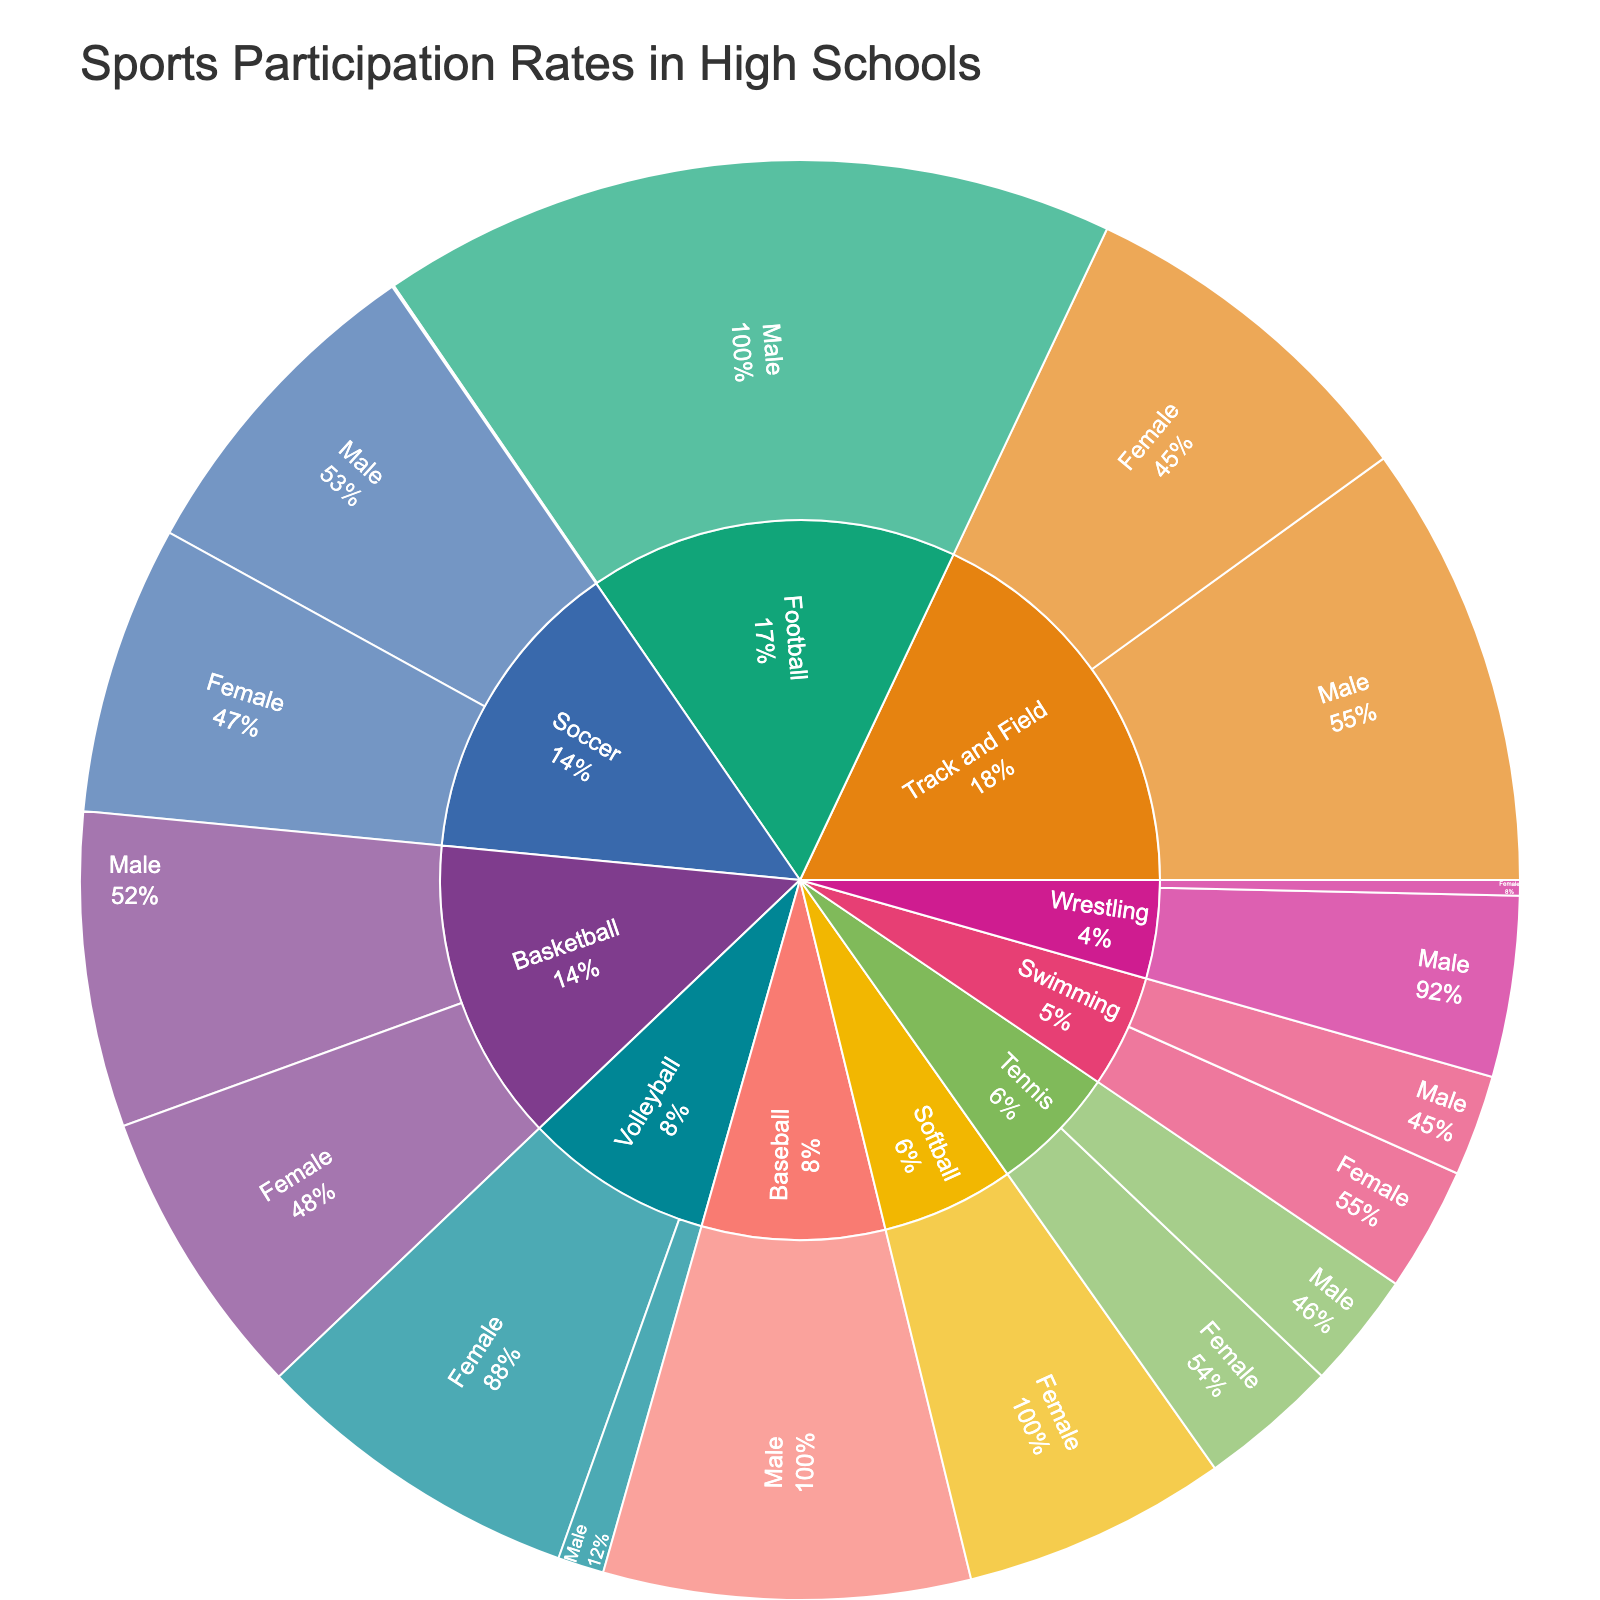what is the sport with the highest overall participation? The sunburst plot shows the participation rates broken down by sport and gender. Identify the largest segment in the plot, which corresponds to the sport with the highest overall participation. The largest segment is for Football (Male) with a count of 1,006,000.
Answer: Football how many students participate in Volleyball overall? Add the participation counts for both male and female Volleyball segments in the sunburst plot. Male Volleyball has 63,000 participants, and Female Volleyball has 452,000 participants. So, the total participation is 63,000 + 452,000.
Answer: 515,000 which sport has more female participants than male participants? Compare the participation rates for male and female segments across all sports. Track and Field (488,000 female to 605,000 male), Tennis (190,000 female to 159,000 male), Swimming (170,000 female to 138,000 male), and Volleyball (452,000 female to 63,000 male) have more female participants than males.
Answer: Track and Field, Tennis, Swimming, Volleyball how many more students play Baseball compared to Softball? Find the participation counts for Baseball and Softball in the sunburst plot. Baseball has 500,000 male participants, and Softball has 362,000 female participants. Calculate the difference: 500,000 - 362,000.
Answer: 138,000 which gender has higher participation in Soccer? Compare the participation rates for male and female Soccer segments in the sunburst plot. Male Soccer has 450,000 participants, while Female Soccer has 394,000 participants.
Answer: Male what percentage of the total Track and Field participants are male? Add the participation rates for male and female Track and Field participants (605,000 male and 488,000 female). Then, calculate the percentage of male participants: (605,000 / (605,000 + 488,000)) * 100.
Answer: 55.35% how does Wrestling participation compare between females and males? Find the participation counts for Wrestling in the sunburst plot. Males have 247,000 participants, while females have 21,000 participants.
Answer: Males participate much more than females which sport has the lowest female participation rate? Identify the smallest segment in the female sports participation categories in the sunburst plot. Female Football has the smallest count with 2,500 participants.
Answer: Football 